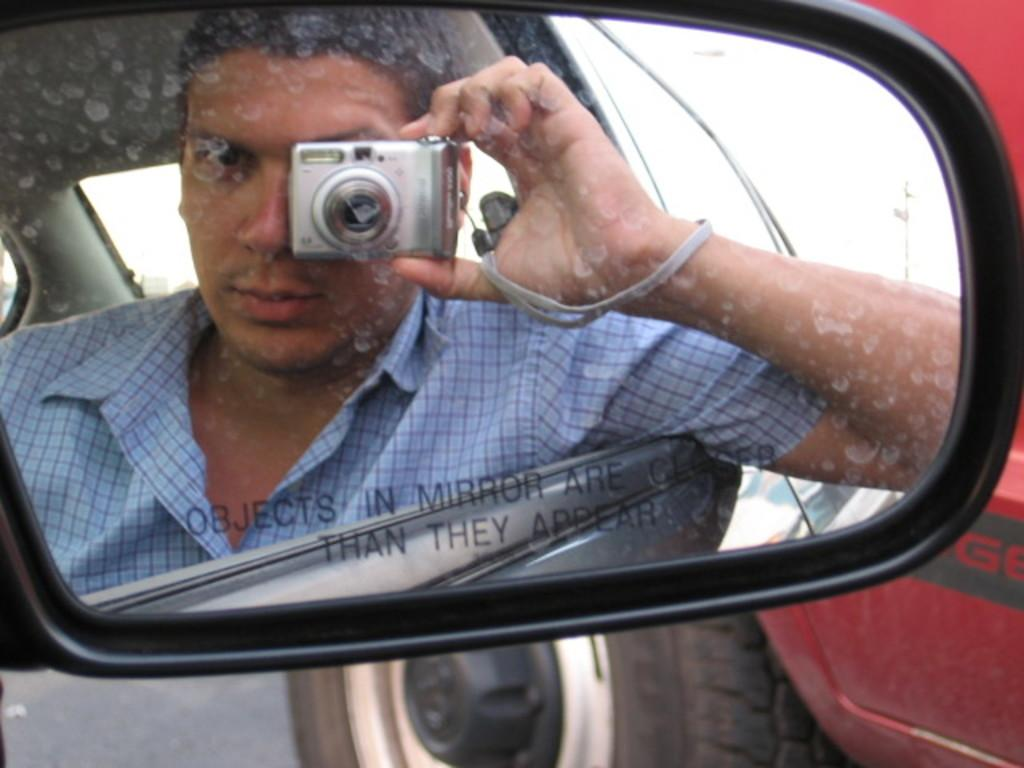What object is present in the image that can reflect images? There is a mirror in the image. Can you describe the person visible in the mirror? The person is holding a camera. What is the person in the mirror doing? The person is holding a camera, which suggests they might be taking a picture. What type of orange instrument can be seen in the image? There is no orange instrument present in the image. 